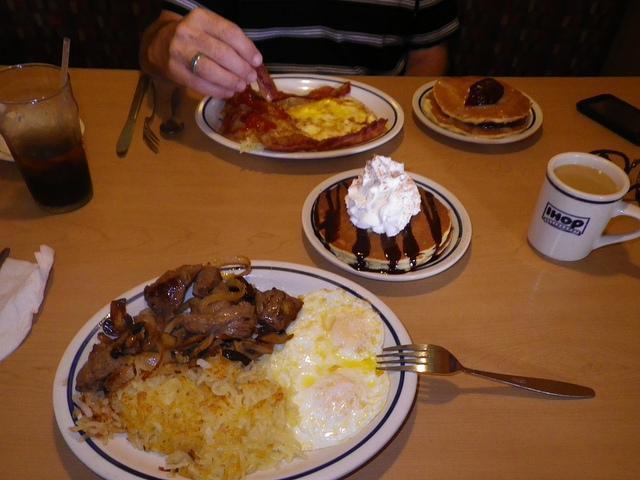How many people are eating at the table?
Give a very brief answer. 2. How many hands are in this picture?
Give a very brief answer. 1. How many forks are there?
Give a very brief answer. 1. How many cups are visible?
Give a very brief answer. 2. How many orange lights are on the back of the bus?
Give a very brief answer. 0. 